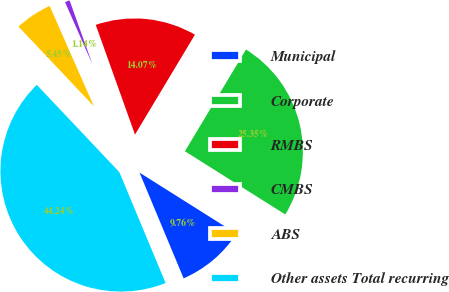Convert chart. <chart><loc_0><loc_0><loc_500><loc_500><pie_chart><fcel>Municipal<fcel>Corporate<fcel>RMBS<fcel>CMBS<fcel>ABS<fcel>Other assets Total recurring<nl><fcel>9.76%<fcel>25.35%<fcel>14.07%<fcel>1.14%<fcel>5.45%<fcel>44.24%<nl></chart> 